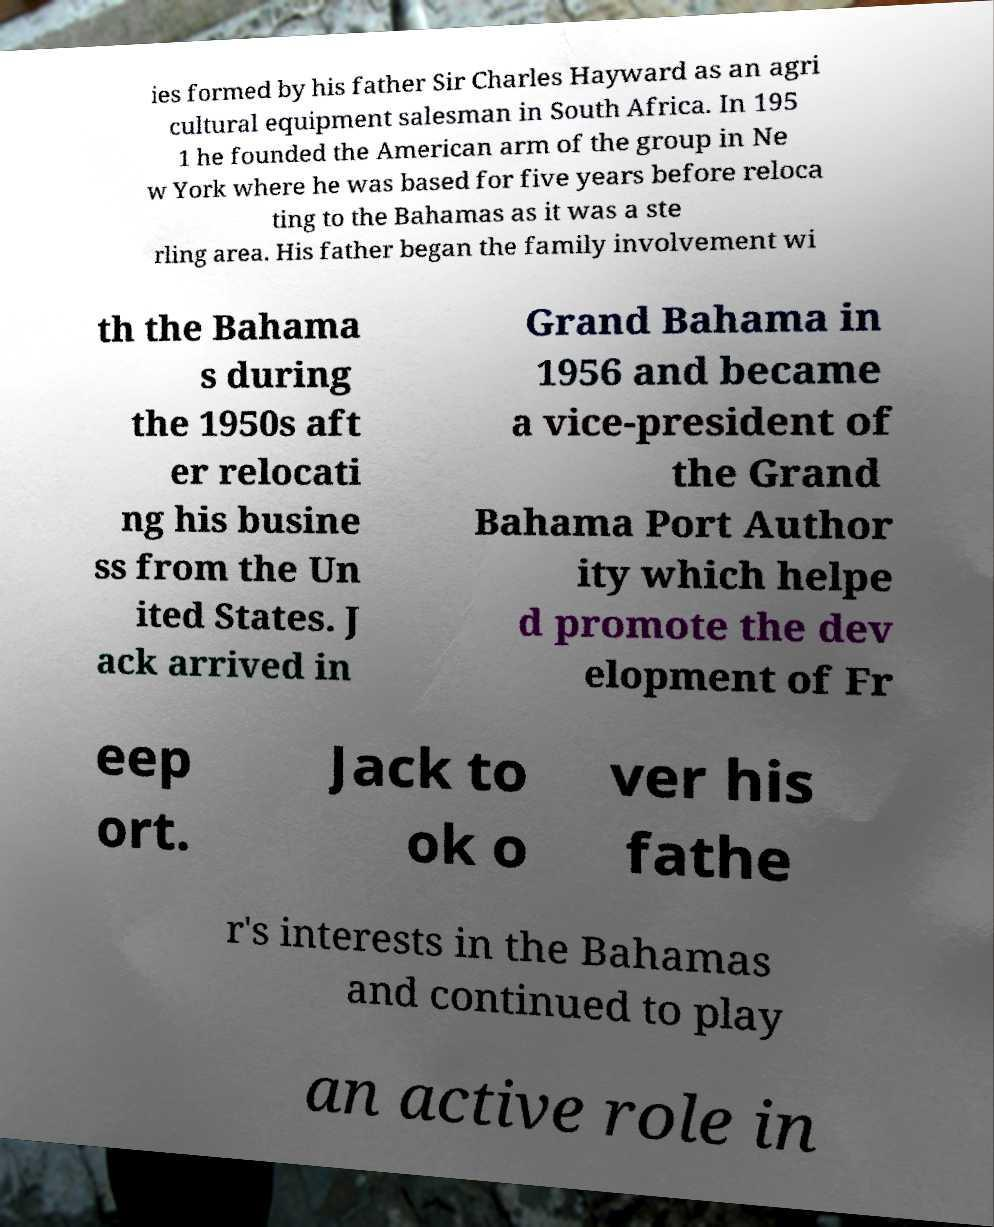Can you accurately transcribe the text from the provided image for me? ies formed by his father Sir Charles Hayward as an agri cultural equipment salesman in South Africa. In 195 1 he founded the American arm of the group in Ne w York where he was based for five years before reloca ting to the Bahamas as it was a ste rling area. His father began the family involvement wi th the Bahama s during the 1950s aft er relocati ng his busine ss from the Un ited States. J ack arrived in Grand Bahama in 1956 and became a vice-president of the Grand Bahama Port Author ity which helpe d promote the dev elopment of Fr eep ort. Jack to ok o ver his fathe r's interests in the Bahamas and continued to play an active role in 